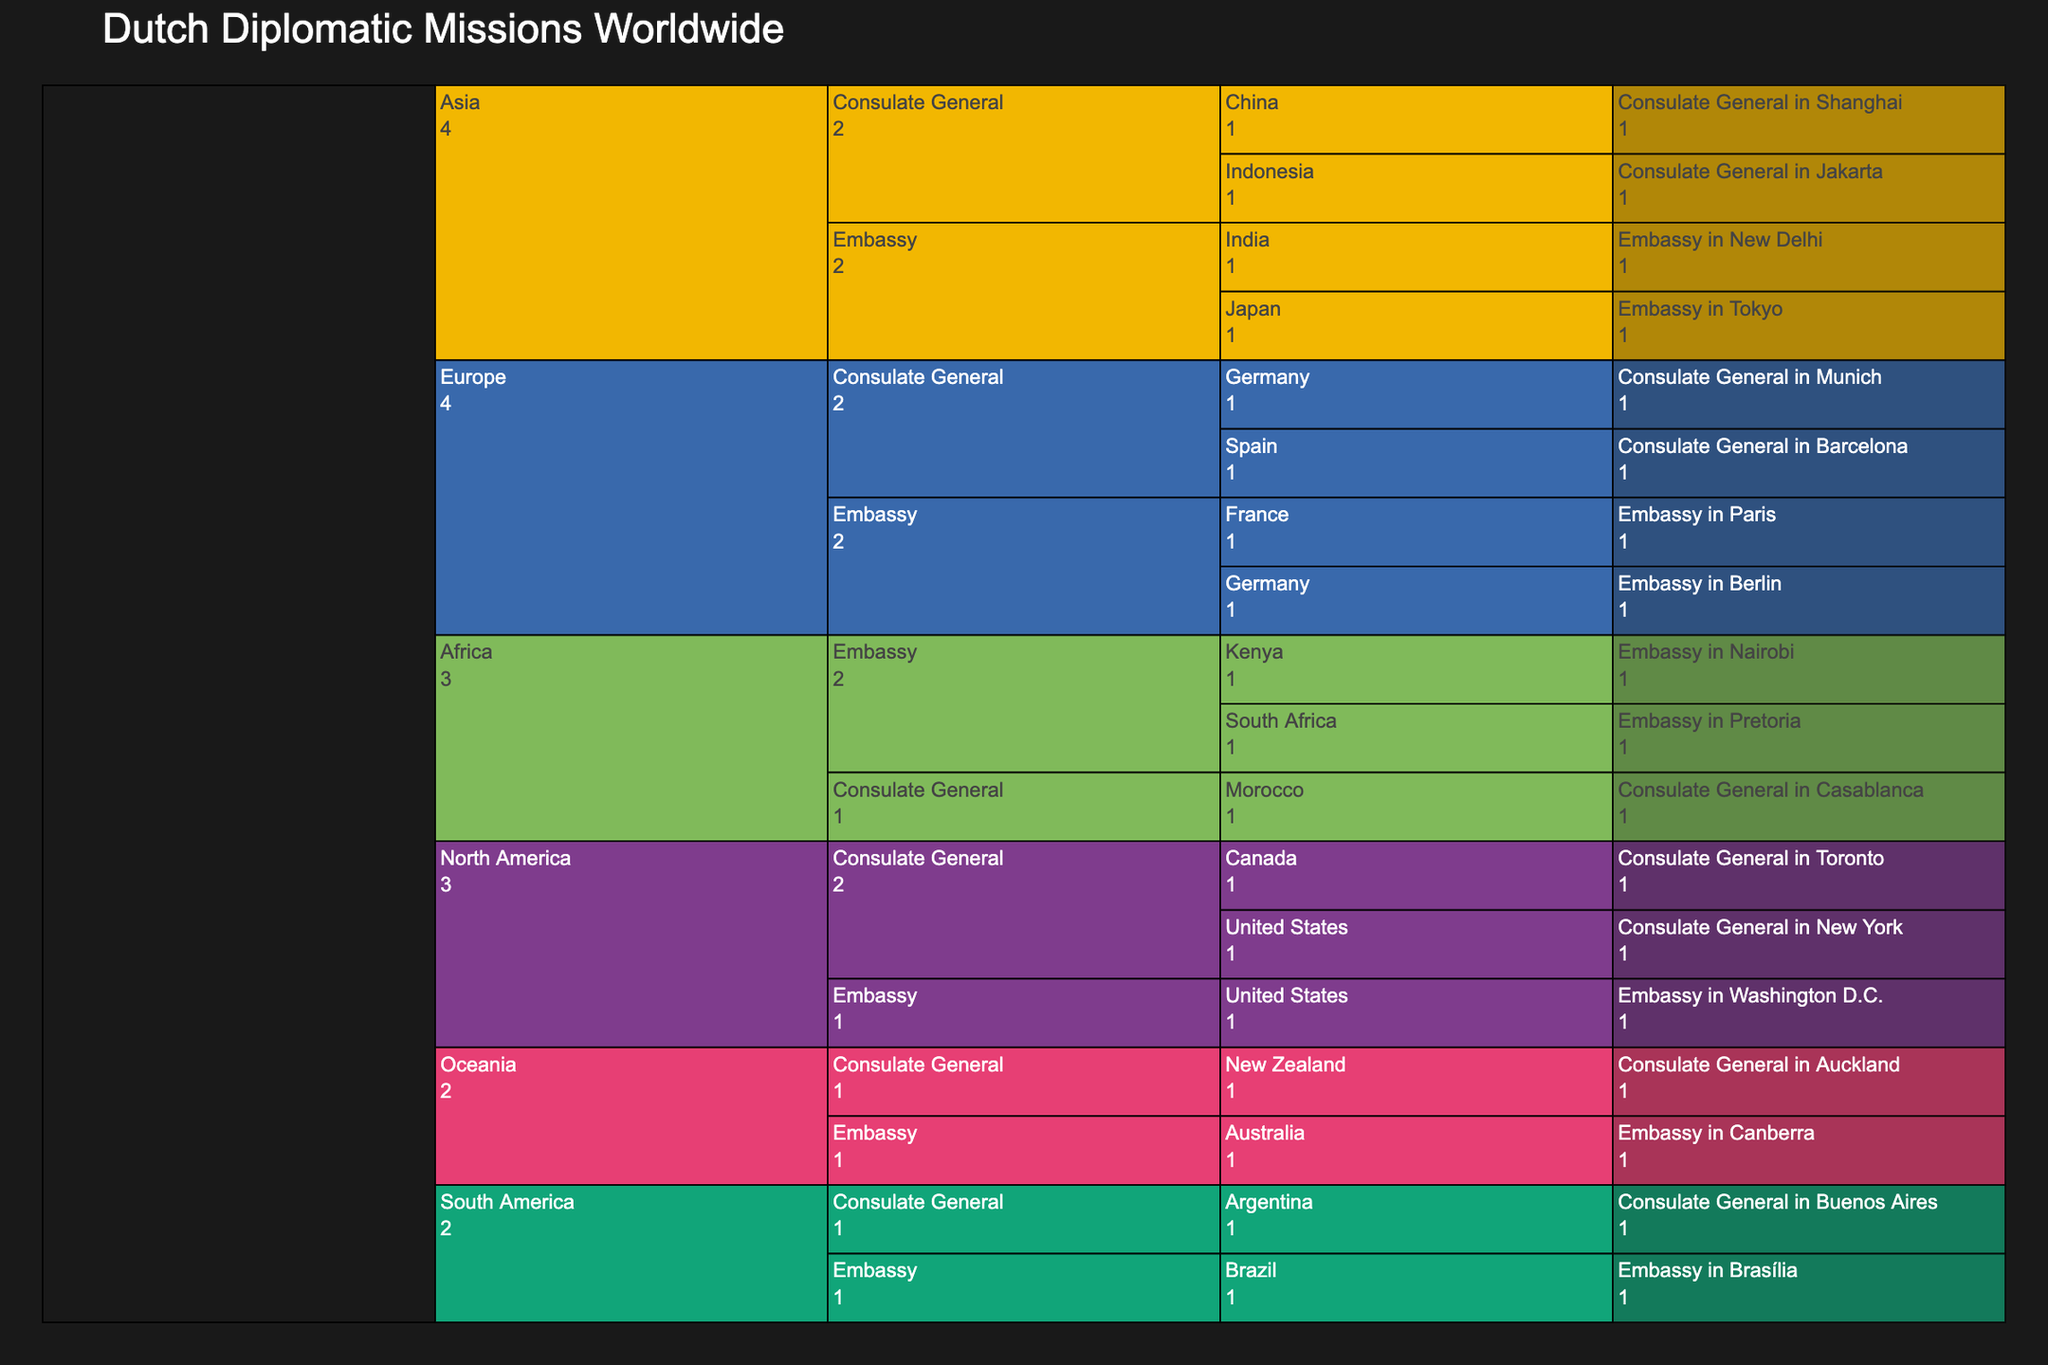How many Dutch embassies are in Europe? To find this, look at the chart section for Europe and count the number of elements under the 'Embassy' category. There are two embassies listed: one in Germany and one in France.
Answer: 2 Which continent has the most Dutch consulate generals? By examining the chart, look for the section that has the most sub-elements under the 'Consulate General' category. Asia has the most consulate generals, with three: China, Indonesia, and New Zealand.
Answer: Asia How many Dutch missions are there in North America? Start by locating North America on the chart and count the total entries under it, including both embassies and consulate generals. There are three missions: one embassy in the United States, and two consulate generals in the United States and Canada.
Answer: 3 Which country in Africa has a Dutch embassy but not a consulate general? To answer this, look under the Africa section in the chart and note which countries have embassies only, without consulate generals. South Africa and Kenya have embassies; only Morocco has a consulate general. Thus, South Africa and Kenya have embassies but not consulate generals.
Answer: South Africa, Kenya Are there more Dutch embassies or consulate generals in Asia? Compare the number of embassies and consulate generals in the Asia section. There are two embassies (Japan, India) and two consulate generals (China, Indonesia). Both categories have the same number.
Answer: Equal What is the ratio of embassies to consulate generals in South America? In South America, find the number of embassies and consulate generals. There is one embassy in Brazil and one consulate general in Argentina. The ratio is therefore 1:1.
Answer: 1:1 Which continent, besides Europe, has both Dutch embassies and consulate generals? Identify continents other than Europe with both types of missions. North America (embassy in the United States and consulate generals in the United States and Canada) fits this criterion.
Answer: North America Which mission type is more prevalent in Oceania, embassies or consulate generals? Look at the Oceania section and count the number of embassies and consulate generals. There is one embassy in Australia and one consulate general in New Zealand, so they are equal.
Answer: Equal 